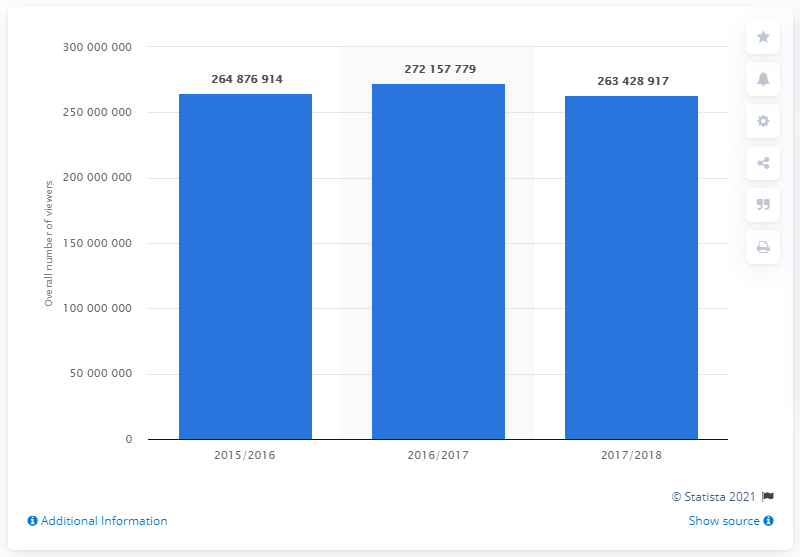Indicate a few pertinent items in this graphic. In 2018, the total number of people who watched soccer matches on all broadcasting channels was 263,428,917. In 2016, a total of 26,342,891 people watched soccer matches on all broadcasting channels. 